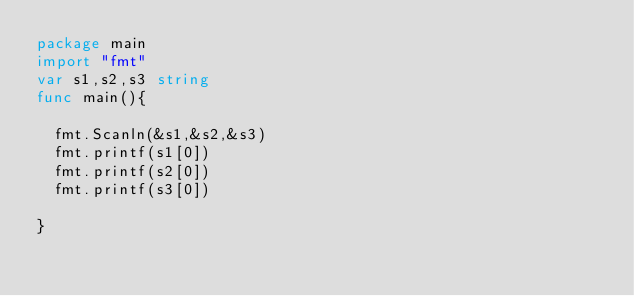<code> <loc_0><loc_0><loc_500><loc_500><_Go_>package main
import "fmt"
var s1,s2,s3 string
func main(){
	
  fmt.Scanln(&s1,&s2,&s3)
  fmt.printf(s1[0])
  fmt.printf(s2[0])
  fmt.printf(s3[0])
  
}
</code> 